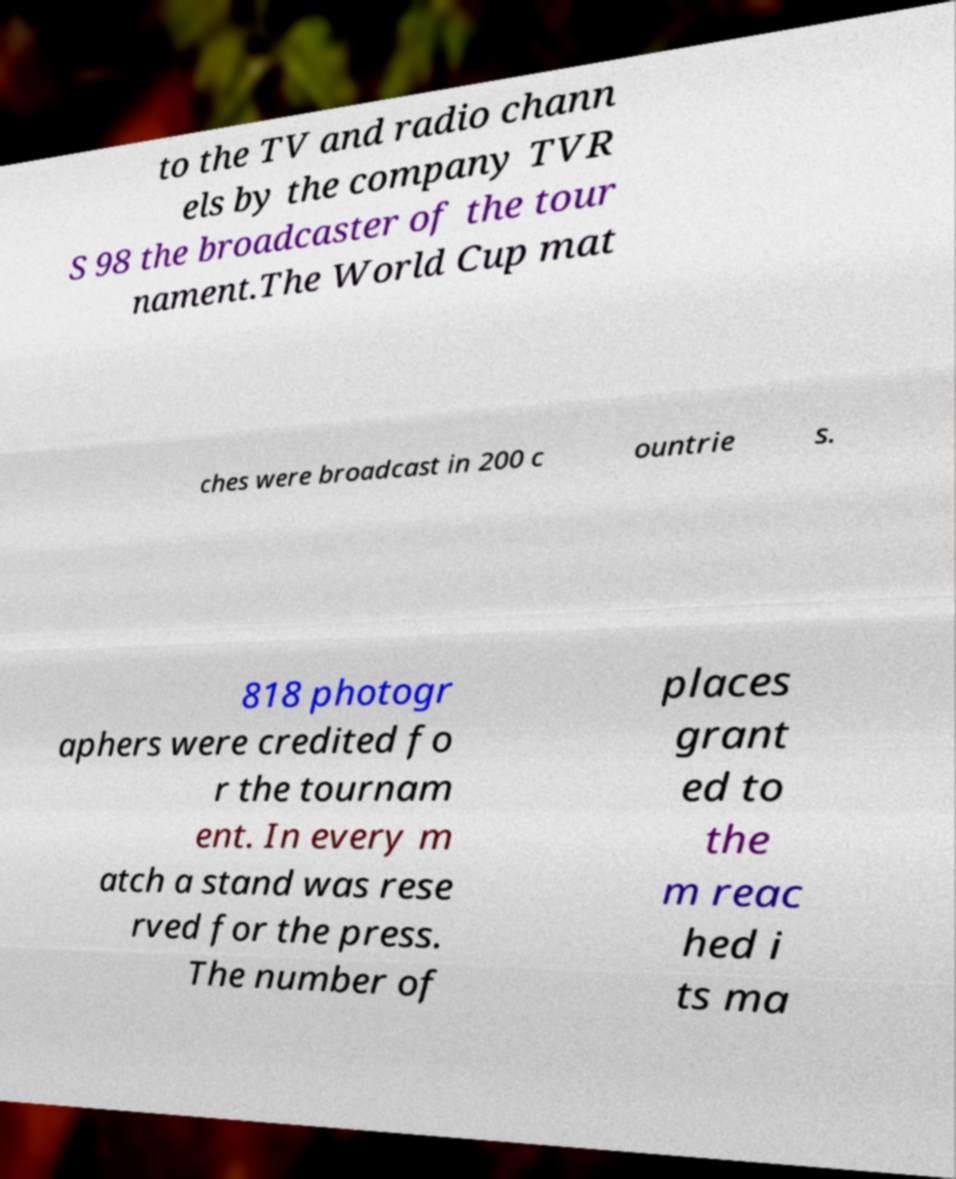Can you read and provide the text displayed in the image?This photo seems to have some interesting text. Can you extract and type it out for me? to the TV and radio chann els by the company TVR S 98 the broadcaster of the tour nament.The World Cup mat ches were broadcast in 200 c ountrie s. 818 photogr aphers were credited fo r the tournam ent. In every m atch a stand was rese rved for the press. The number of places grant ed to the m reac hed i ts ma 